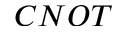<formula> <loc_0><loc_0><loc_500><loc_500>C N O T</formula> 